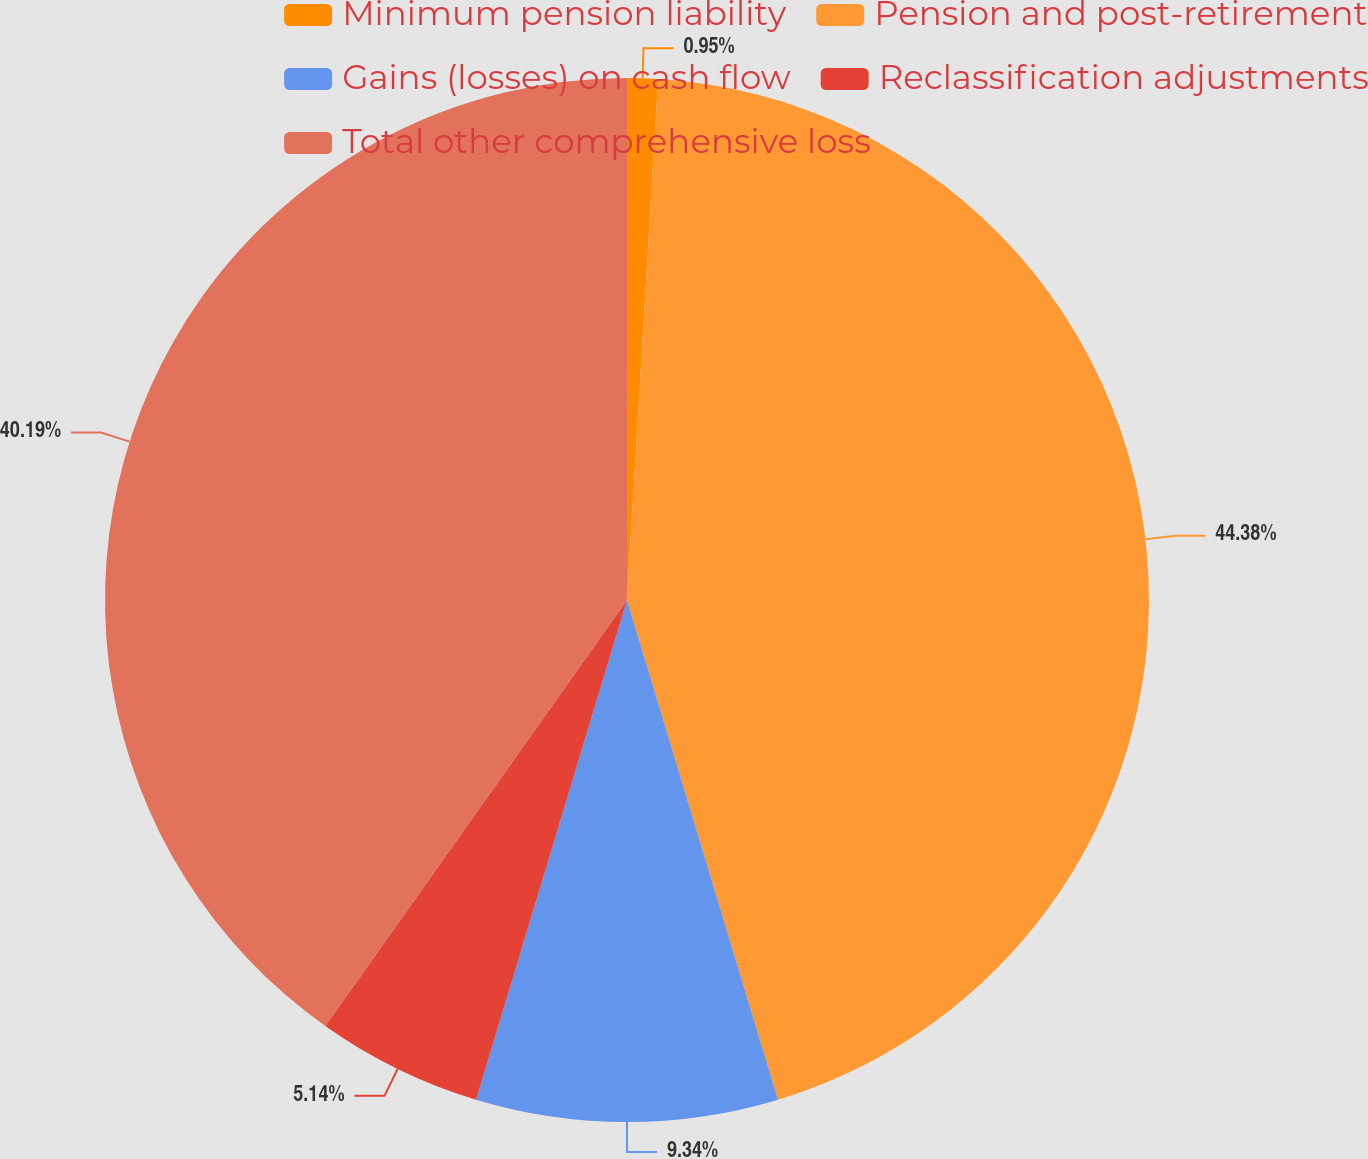<chart> <loc_0><loc_0><loc_500><loc_500><pie_chart><fcel>Minimum pension liability<fcel>Pension and post-retirement<fcel>Gains (losses) on cash flow<fcel>Reclassification adjustments<fcel>Total other comprehensive loss<nl><fcel>0.95%<fcel>44.38%<fcel>9.34%<fcel>5.14%<fcel>40.19%<nl></chart> 